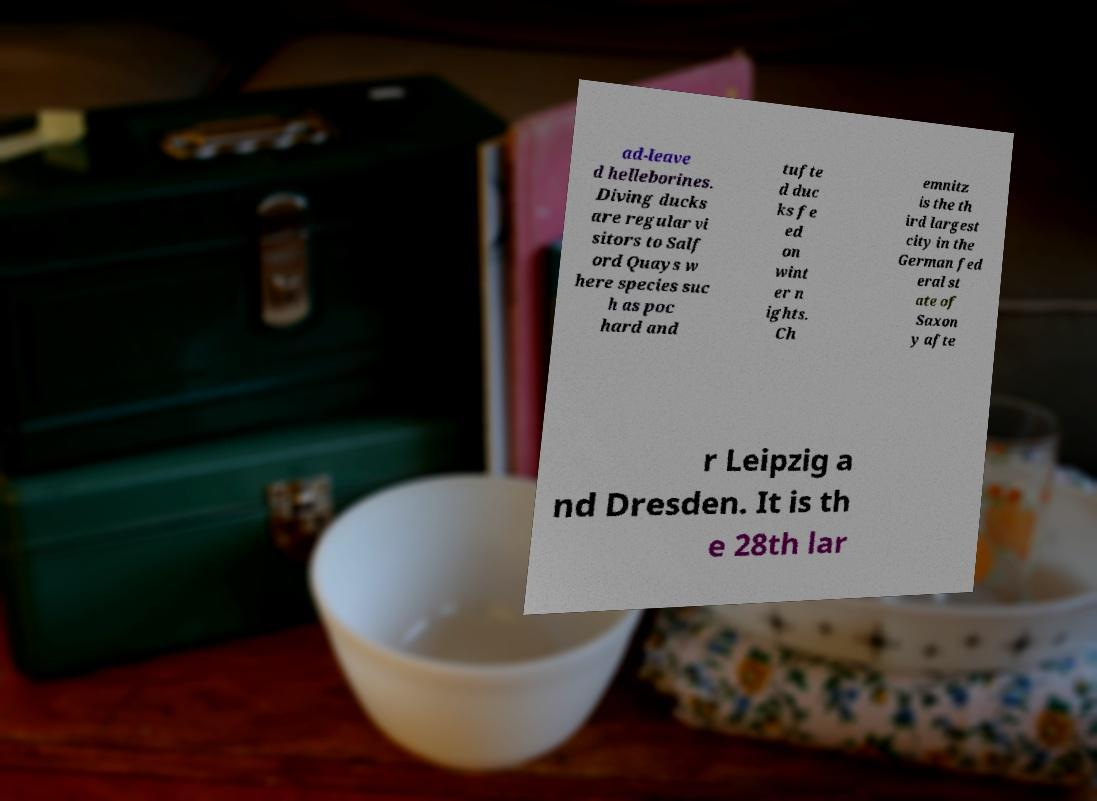There's text embedded in this image that I need extracted. Can you transcribe it verbatim? ad-leave d helleborines. Diving ducks are regular vi sitors to Salf ord Quays w here species suc h as poc hard and tufte d duc ks fe ed on wint er n ights. Ch emnitz is the th ird largest city in the German fed eral st ate of Saxon y afte r Leipzig a nd Dresden. It is th e 28th lar 